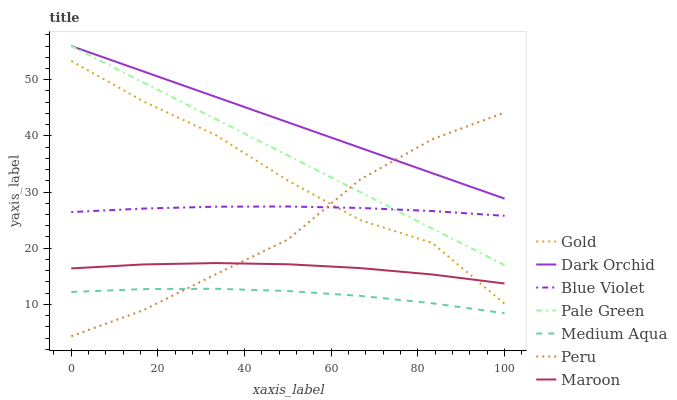Does Medium Aqua have the minimum area under the curve?
Answer yes or no. Yes. Does Dark Orchid have the maximum area under the curve?
Answer yes or no. Yes. Does Pale Green have the minimum area under the curve?
Answer yes or no. No. Does Pale Green have the maximum area under the curve?
Answer yes or no. No. Is Pale Green the smoothest?
Answer yes or no. Yes. Is Gold the roughest?
Answer yes or no. Yes. Is Dark Orchid the smoothest?
Answer yes or no. No. Is Dark Orchid the roughest?
Answer yes or no. No. Does Peru have the lowest value?
Answer yes or no. Yes. Does Pale Green have the lowest value?
Answer yes or no. No. Does Pale Green have the highest value?
Answer yes or no. Yes. Does Medium Aqua have the highest value?
Answer yes or no. No. Is Medium Aqua less than Maroon?
Answer yes or no. Yes. Is Dark Orchid greater than Medium Aqua?
Answer yes or no. Yes. Does Peru intersect Medium Aqua?
Answer yes or no. Yes. Is Peru less than Medium Aqua?
Answer yes or no. No. Is Peru greater than Medium Aqua?
Answer yes or no. No. Does Medium Aqua intersect Maroon?
Answer yes or no. No. 